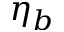Convert formula to latex. <formula><loc_0><loc_0><loc_500><loc_500>\eta _ { b }</formula> 